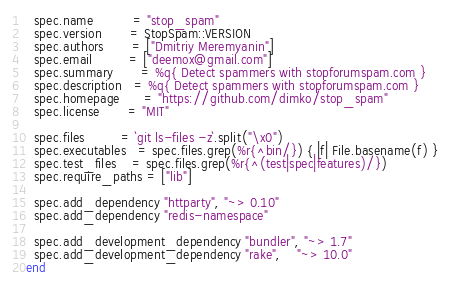Convert code to text. <code><loc_0><loc_0><loc_500><loc_500><_Ruby_>  spec.name          = "stop_spam"
  spec.version       = StopSpam::VERSION
  spec.authors       = ["Dmitriy Meremyanin"]
  spec.email         = ["deemox@gmail.com"]
  spec.summary       = %q{ Detect spammers with stopforumspam.com }
  spec.description   = %q{ Detect spammers with stopforumspam.com }
  spec.homepage      = "https://github.com/dimko/stop_spam"
  spec.license       = "MIT"

  spec.files         = `git ls-files -z`.split("\x0")
  spec.executables   = spec.files.grep(%r{^bin/}) { |f| File.basename(f) }
  spec.test_files    = spec.files.grep(%r{^(test|spec|features)/})
  spec.require_paths = ["lib"]

  spec.add_dependency "httparty", "~> 0.10"
  spec.add_dependency "redis-namespace"

  spec.add_development_dependency "bundler", "~> 1.7"
  spec.add_development_dependency "rake",    "~> 10.0"
end
</code> 